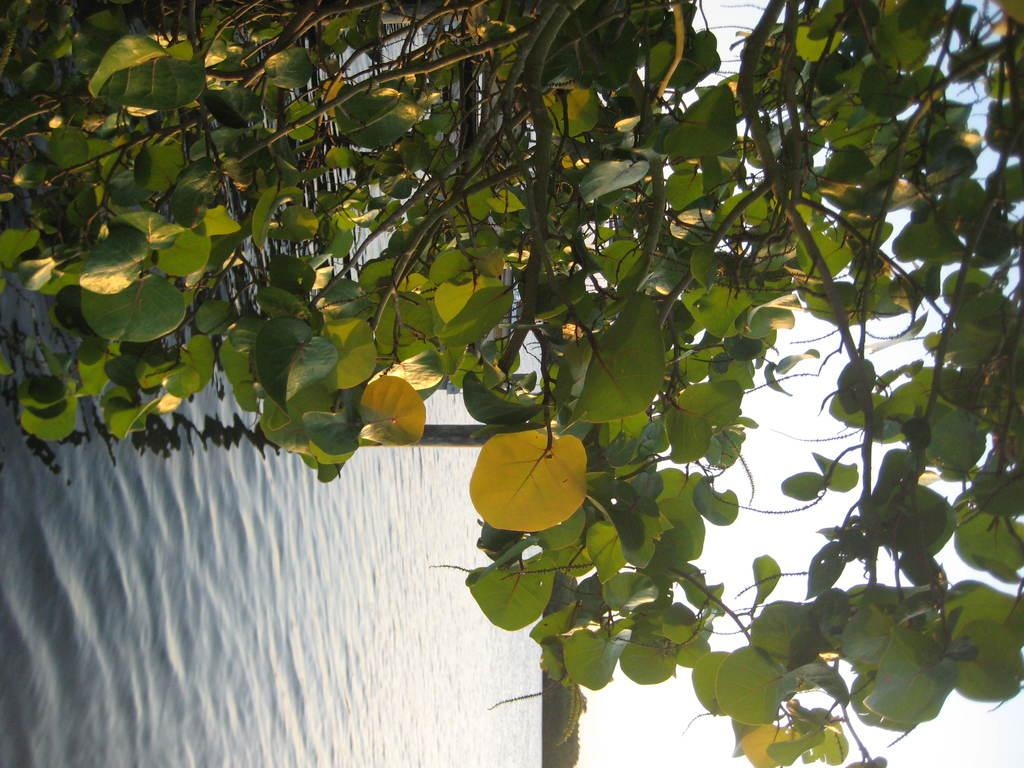What type of vegetation is present in the image? There are leaves of a tree in the image. What is visible behind the leaves? There is water visible behind the leaves. What else can be seen at the bottom of the image? There are trees at the bottom of the image. What part of the sky is visible in the image? The sky is visible on the right side of the image. What type of stamp is visible on the tree leaves in the image? There is no stamp present on the tree leaves in the image. How many employees does the company depicted in the image have? There is no company present in the image. 